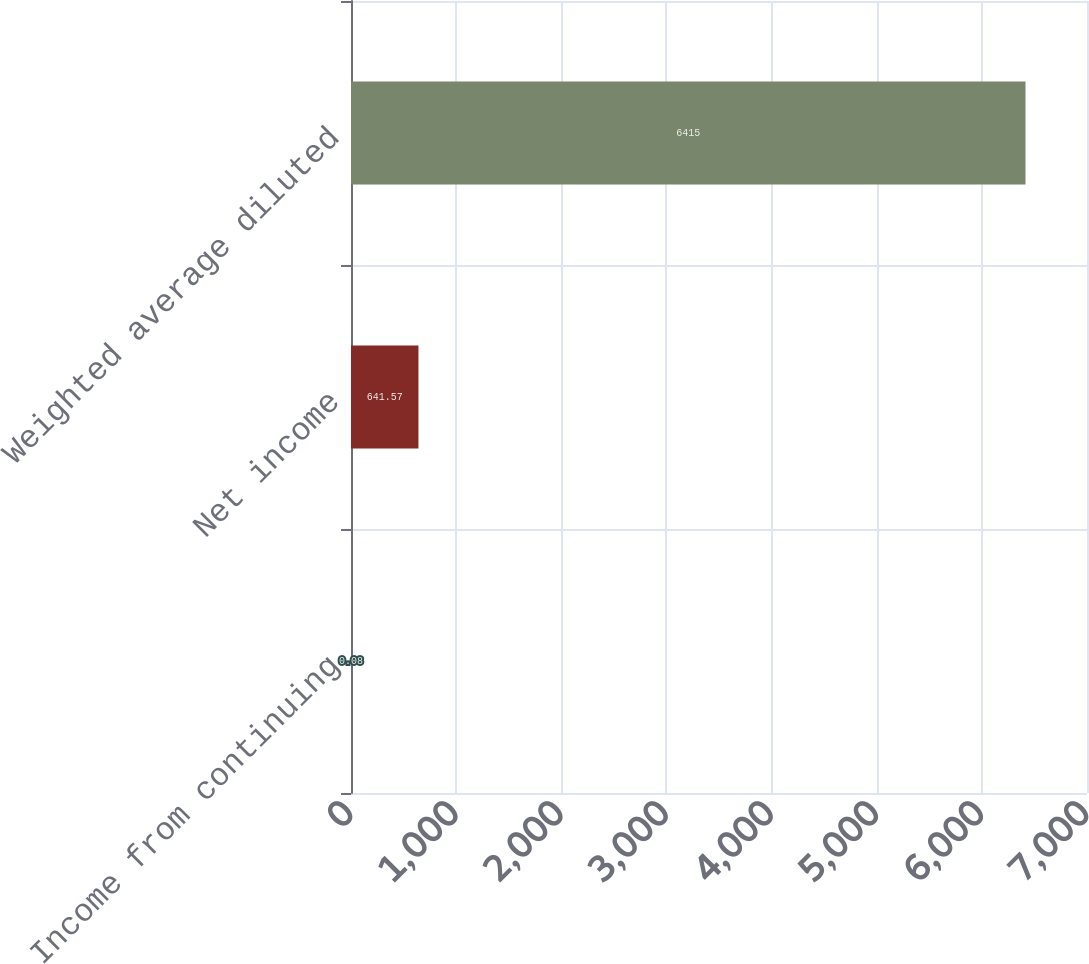Convert chart to OTSL. <chart><loc_0><loc_0><loc_500><loc_500><bar_chart><fcel>Income from continuing<fcel>Net income<fcel>Weighted average diluted<nl><fcel>0.08<fcel>641.57<fcel>6415<nl></chart> 